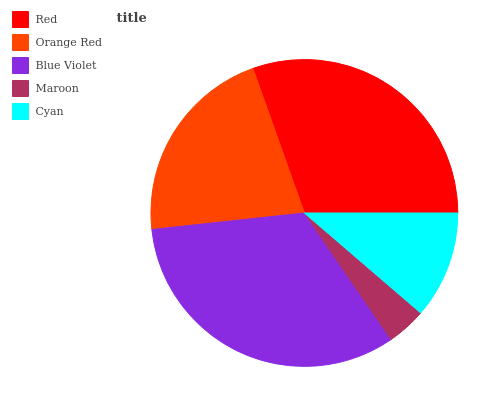Is Maroon the minimum?
Answer yes or no. Yes. Is Blue Violet the maximum?
Answer yes or no. Yes. Is Orange Red the minimum?
Answer yes or no. No. Is Orange Red the maximum?
Answer yes or no. No. Is Red greater than Orange Red?
Answer yes or no. Yes. Is Orange Red less than Red?
Answer yes or no. Yes. Is Orange Red greater than Red?
Answer yes or no. No. Is Red less than Orange Red?
Answer yes or no. No. Is Orange Red the high median?
Answer yes or no. Yes. Is Orange Red the low median?
Answer yes or no. Yes. Is Maroon the high median?
Answer yes or no. No. Is Maroon the low median?
Answer yes or no. No. 